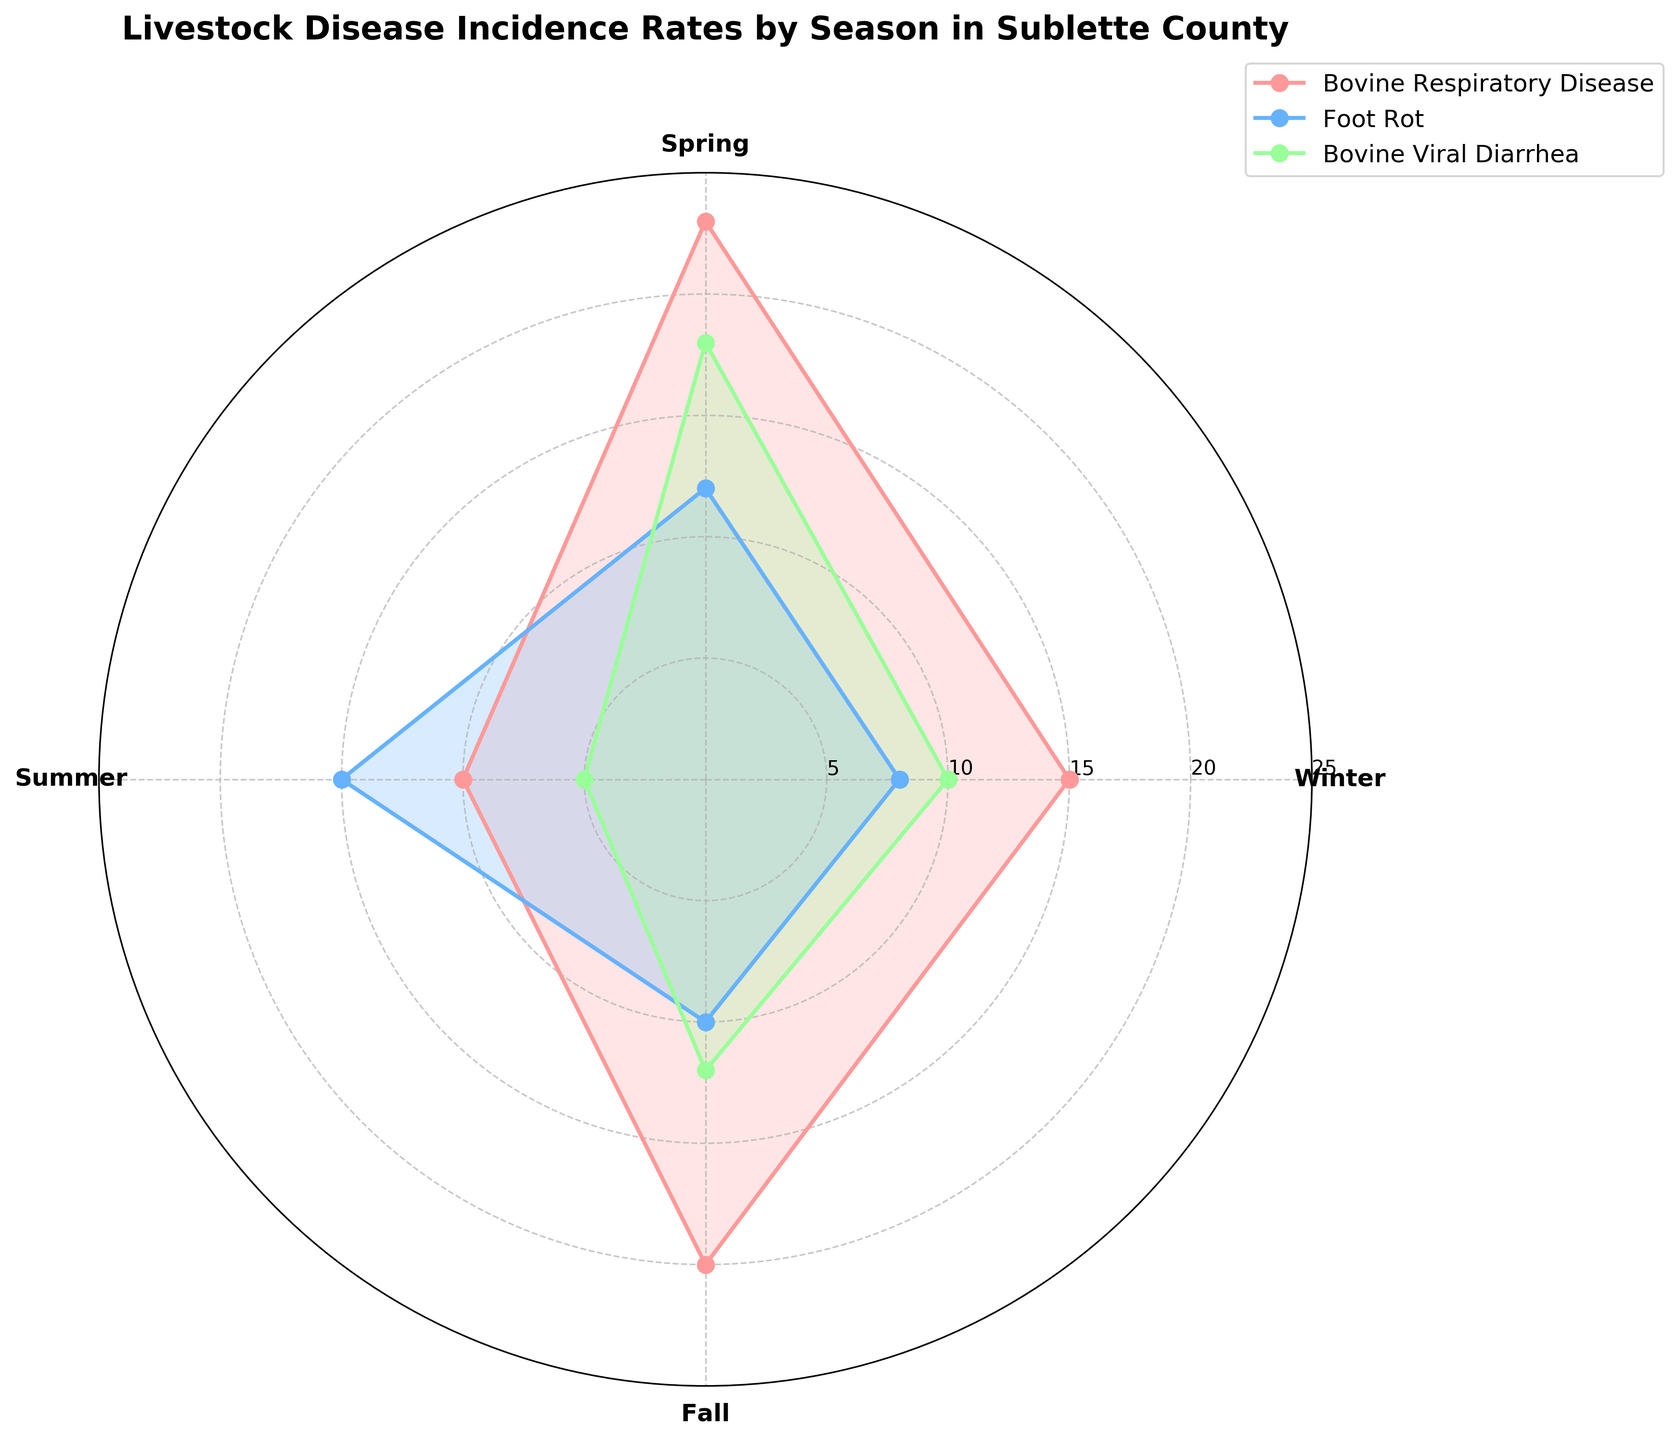What is the title of the figure? The title is usually located at the top of the figure. In this case, the title clearly mentions the subject and location of the data.
Answer: Livestock Disease Incidence Rates by Season in Sublette County Which season has the highest incidence rate of Bovine Respiratory Disease? To determine this, look at the segments corresponding to Bovine Respiratory Disease in each season and identify the one with the maximum value.
Answer: Spring Which disease has the lowest incidence rate in Summer? Examine the sections of the polar area chart corresponding to the summer season and find the one with the smallest value.
Answer: Bovine Viral Diarrhea What is the difference in the incidence rate of Foot Rot between Spring and Winter? Identify the incidence rates of Foot Rot for both Spring and Winter from the figure and subtract the Winter value from the Spring value.
Answer: 4 Which season shows the highest combined incidence rate for all three diseases? Calculate the sum of the incidence rates for Bovine Respiratory Disease, Foot Rot, and Bovine Viral Diarrhea for each season, then identify the season with the highest total.
Answer: Spring How do the incidence rates of Foot Rot change from Winter to Summer? Track the incidence rate of Foot Rot across Winter, Spring, and Summer sequentially to observe the trend.
Answer: Increase, then decrease Are the incidence rates for Bovine Viral Diarrhea in Winter and Fall equal? Compare the segments representing Bovine Viral Diarrhea during Winter and Fall to see if they reach the same value.
Answer: No Which disease shows the most variability in incidence rates across the seasons? Determine this by comparing the range (difference between maximum and minimum values) of incidence rates for each disease across all seasons.
Answer: Bovine Viral Diarrhea Is the incidence rate of Foot Rot in Summer higher than in Fall? Compare the incidence rates for Foot Rot in the Summer and Fall sections to determine which is higher.
Answer: Yes What is the combined incidence rate for Bovine Respiratory Disease and Bovine Viral Diarrhea in Winter? Add the incidence rates of Bovine Respiratory Disease and Bovine Viral Diarrhea for Winter.
Answer: 25 